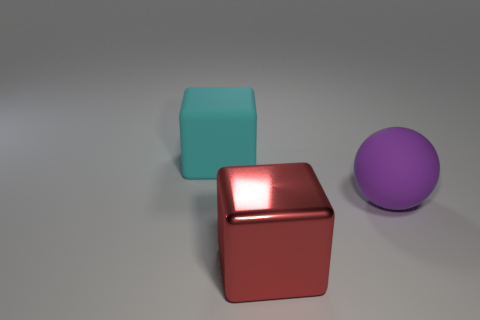Add 1 purple spheres. How many objects exist? 4 Subtract all blocks. How many objects are left? 1 Subtract 0 blue cubes. How many objects are left? 3 Subtract all large yellow metal objects. Subtract all large cyan rubber objects. How many objects are left? 2 Add 2 red shiny blocks. How many red shiny blocks are left? 3 Add 2 blue matte cylinders. How many blue matte cylinders exist? 2 